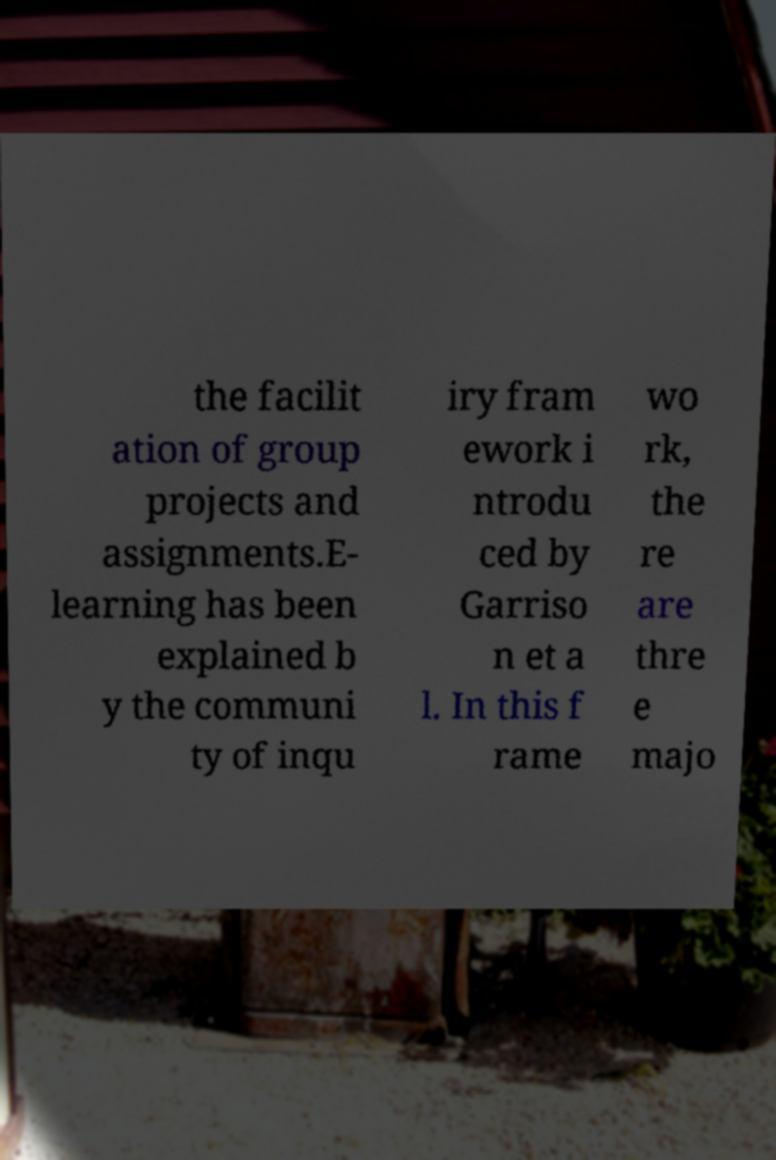Can you read and provide the text displayed in the image?This photo seems to have some interesting text. Can you extract and type it out for me? the facilit ation of group projects and assignments.E- learning has been explained b y the communi ty of inqu iry fram ework i ntrodu ced by Garriso n et a l. In this f rame wo rk, the re are thre e majo 